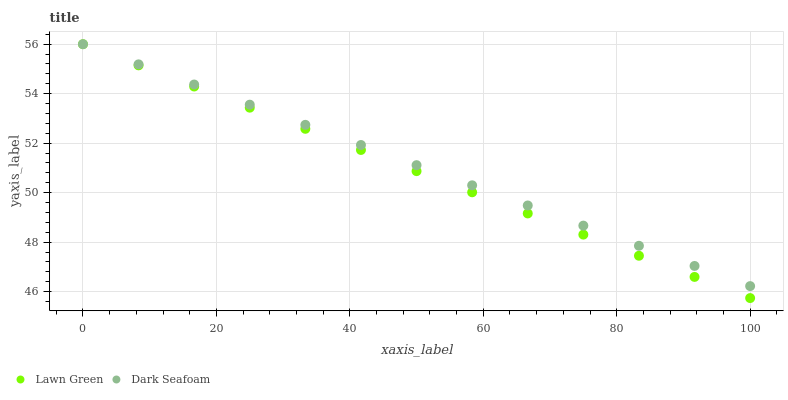Does Lawn Green have the minimum area under the curve?
Answer yes or no. Yes. Does Dark Seafoam have the maximum area under the curve?
Answer yes or no. Yes. Does Dark Seafoam have the minimum area under the curve?
Answer yes or no. No. Is Lawn Green the smoothest?
Answer yes or no. Yes. Is Dark Seafoam the roughest?
Answer yes or no. Yes. Is Dark Seafoam the smoothest?
Answer yes or no. No. Does Lawn Green have the lowest value?
Answer yes or no. Yes. Does Dark Seafoam have the lowest value?
Answer yes or no. No. Does Dark Seafoam have the highest value?
Answer yes or no. Yes. Does Dark Seafoam intersect Lawn Green?
Answer yes or no. Yes. Is Dark Seafoam less than Lawn Green?
Answer yes or no. No. Is Dark Seafoam greater than Lawn Green?
Answer yes or no. No. 